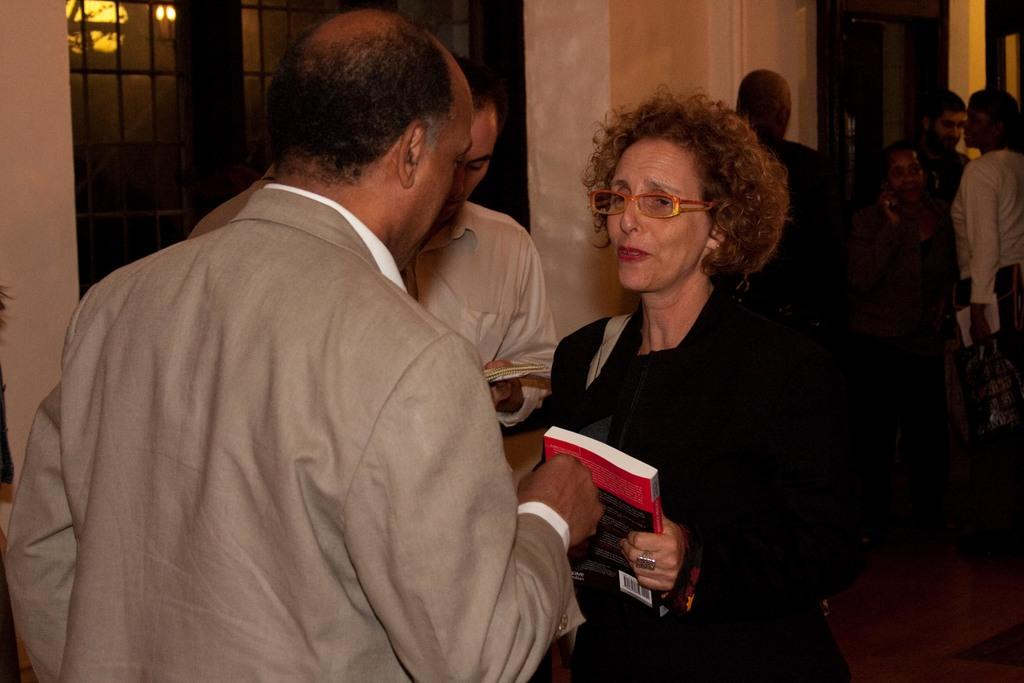How many persons are in the image? There are persons in the image. What is one person holding in the image? One person is holding a book with their hand. Can you describe the person holding the book? The person holding the book has spectacles. What can be seen in the background of the image? There is a wall, lights, and glasses in the background of the image. What type of edge can be seen on the tongue of the person holding the book in the image? There is no tongue visible in the image, and therefore no edge can be seen on it. 